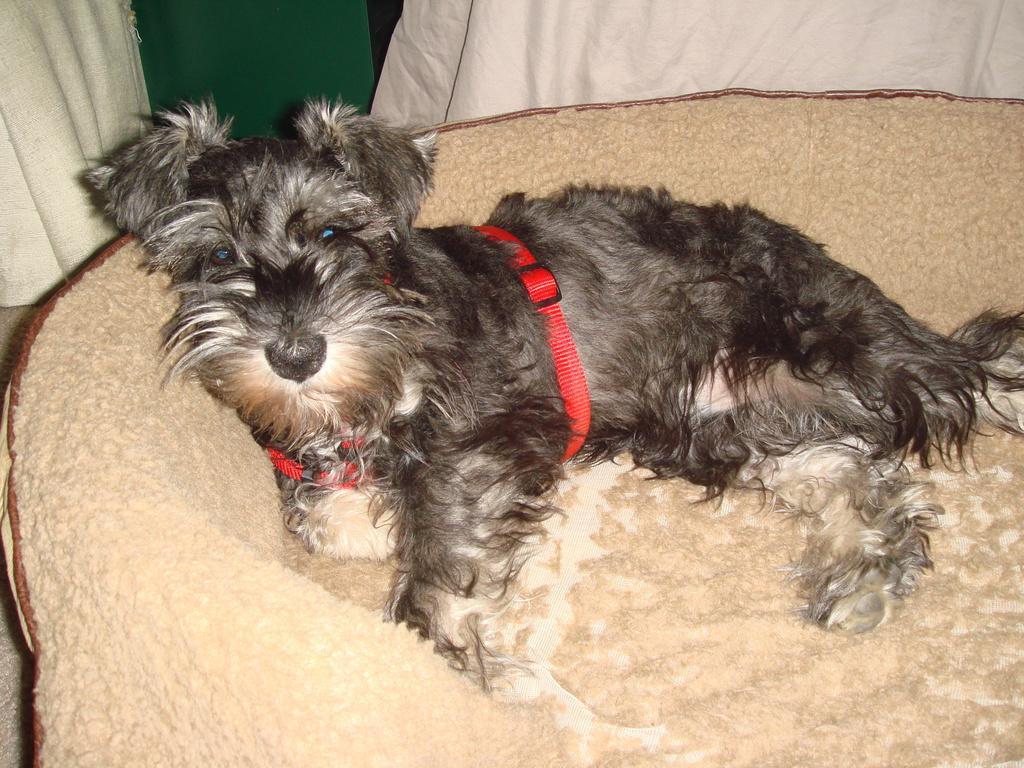In one or two sentences, can you explain what this image depicts? In this image I can see a dog in white and black color on the cream color surface. Background I can see a cloth in white and green color. 